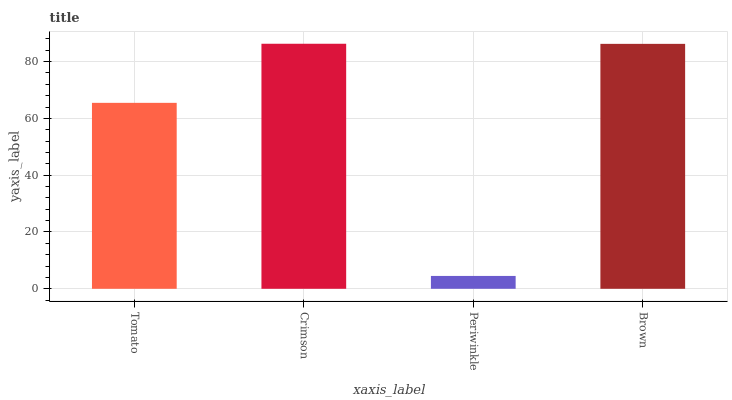Is Periwinkle the minimum?
Answer yes or no. Yes. Is Crimson the maximum?
Answer yes or no. Yes. Is Crimson the minimum?
Answer yes or no. No. Is Periwinkle the maximum?
Answer yes or no. No. Is Crimson greater than Periwinkle?
Answer yes or no. Yes. Is Periwinkle less than Crimson?
Answer yes or no. Yes. Is Periwinkle greater than Crimson?
Answer yes or no. No. Is Crimson less than Periwinkle?
Answer yes or no. No. Is Brown the high median?
Answer yes or no. Yes. Is Tomato the low median?
Answer yes or no. Yes. Is Tomato the high median?
Answer yes or no. No. Is Periwinkle the low median?
Answer yes or no. No. 